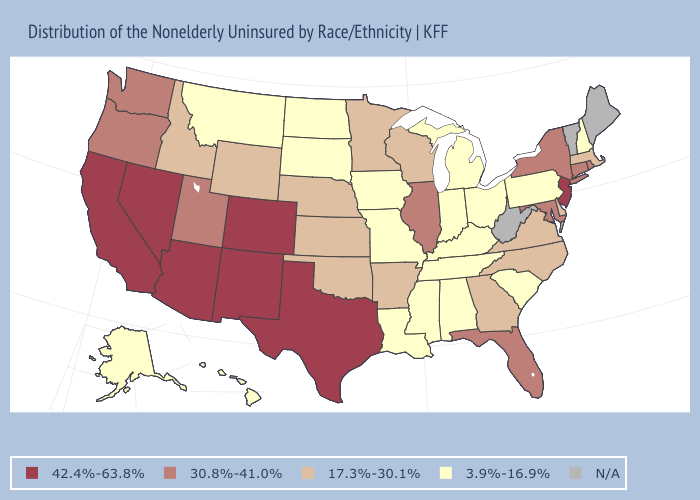Does the map have missing data?
Write a very short answer. Yes. Name the states that have a value in the range 3.9%-16.9%?
Quick response, please. Alabama, Alaska, Hawaii, Indiana, Iowa, Kentucky, Louisiana, Michigan, Mississippi, Missouri, Montana, New Hampshire, North Dakota, Ohio, Pennsylvania, South Carolina, South Dakota, Tennessee. Is the legend a continuous bar?
Quick response, please. No. What is the highest value in the USA?
Write a very short answer. 42.4%-63.8%. What is the highest value in the USA?
Give a very brief answer. 42.4%-63.8%. Which states have the lowest value in the South?
Write a very short answer. Alabama, Kentucky, Louisiana, Mississippi, South Carolina, Tennessee. What is the value of North Dakota?
Give a very brief answer. 3.9%-16.9%. Which states have the highest value in the USA?
Give a very brief answer. Arizona, California, Colorado, Nevada, New Jersey, New Mexico, Texas. What is the highest value in the South ?
Concise answer only. 42.4%-63.8%. Does Georgia have the lowest value in the USA?
Quick response, please. No. Among the states that border New Jersey , does New York have the lowest value?
Concise answer only. No. Which states hav the highest value in the South?
Concise answer only. Texas. 